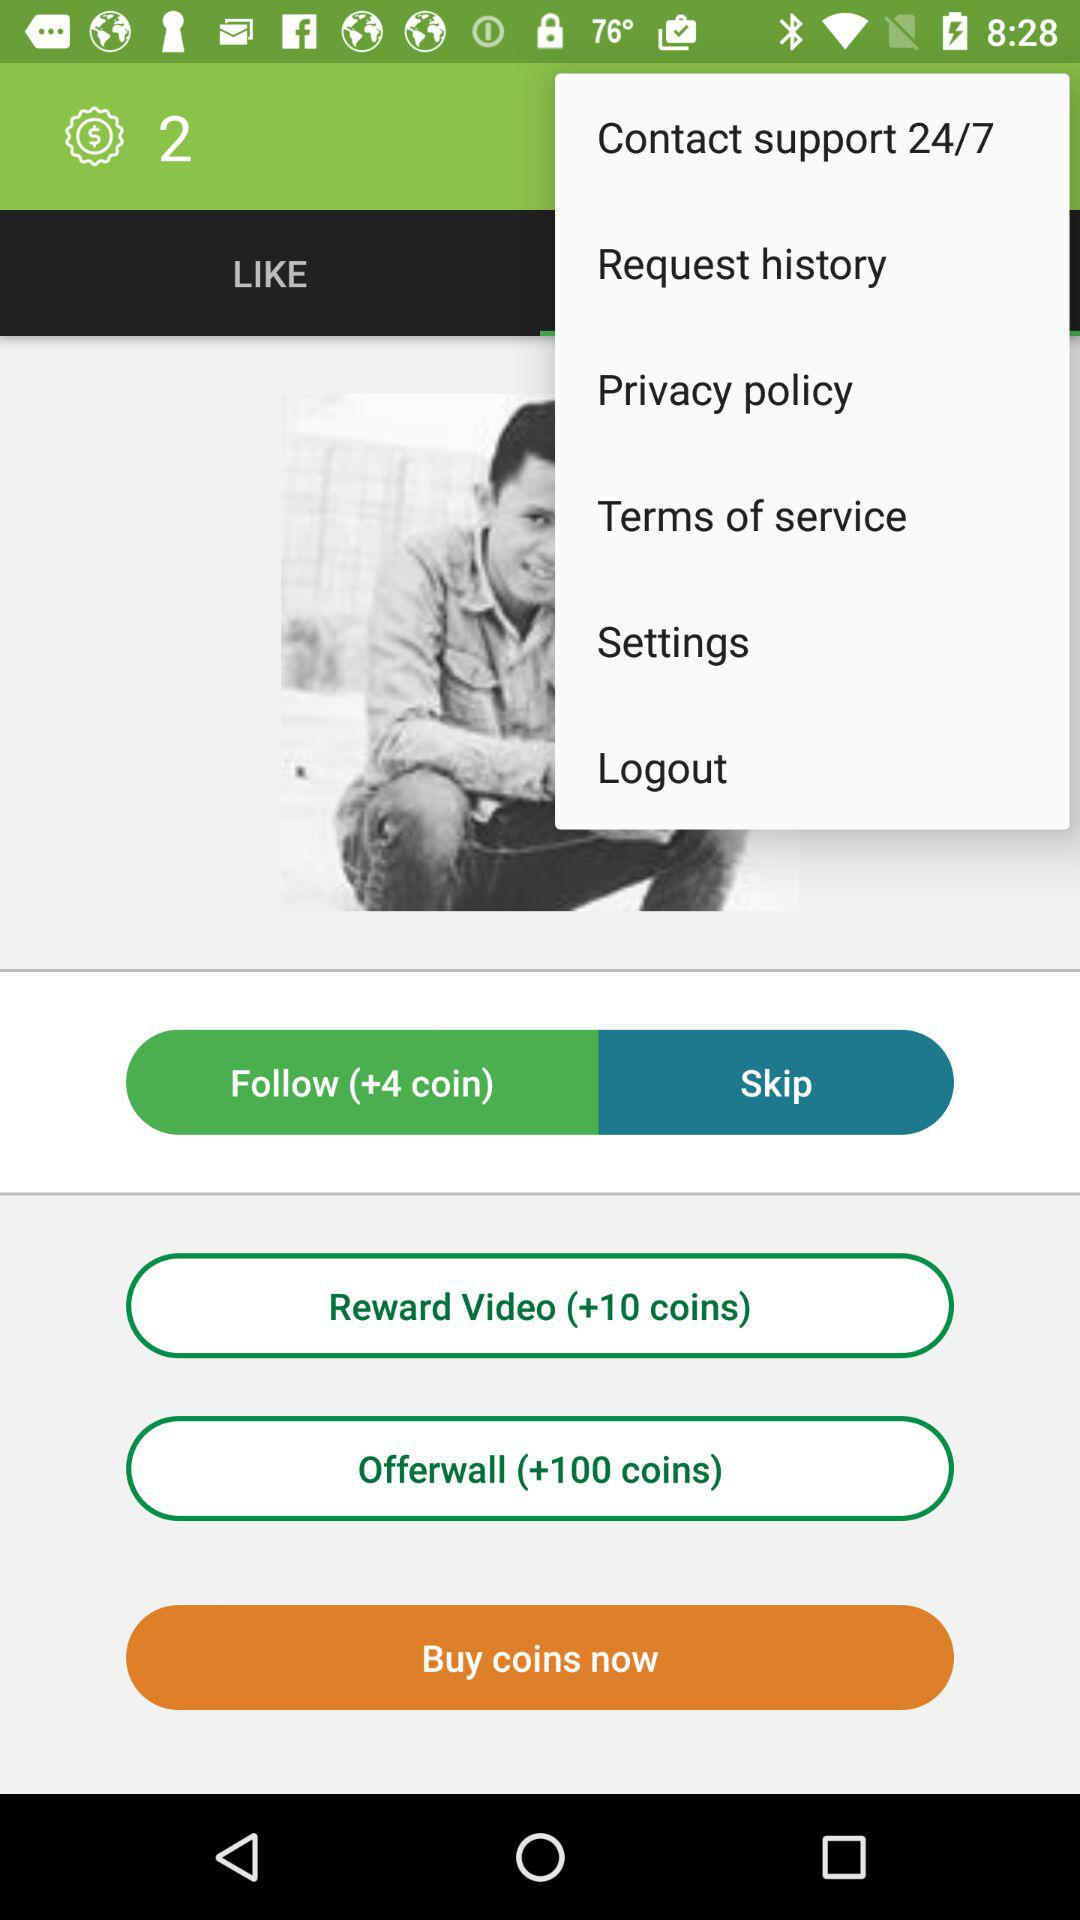By performing which task additional 4 coins will be earned? The additional 4 coins will be earned by performing the "Follow" task. 